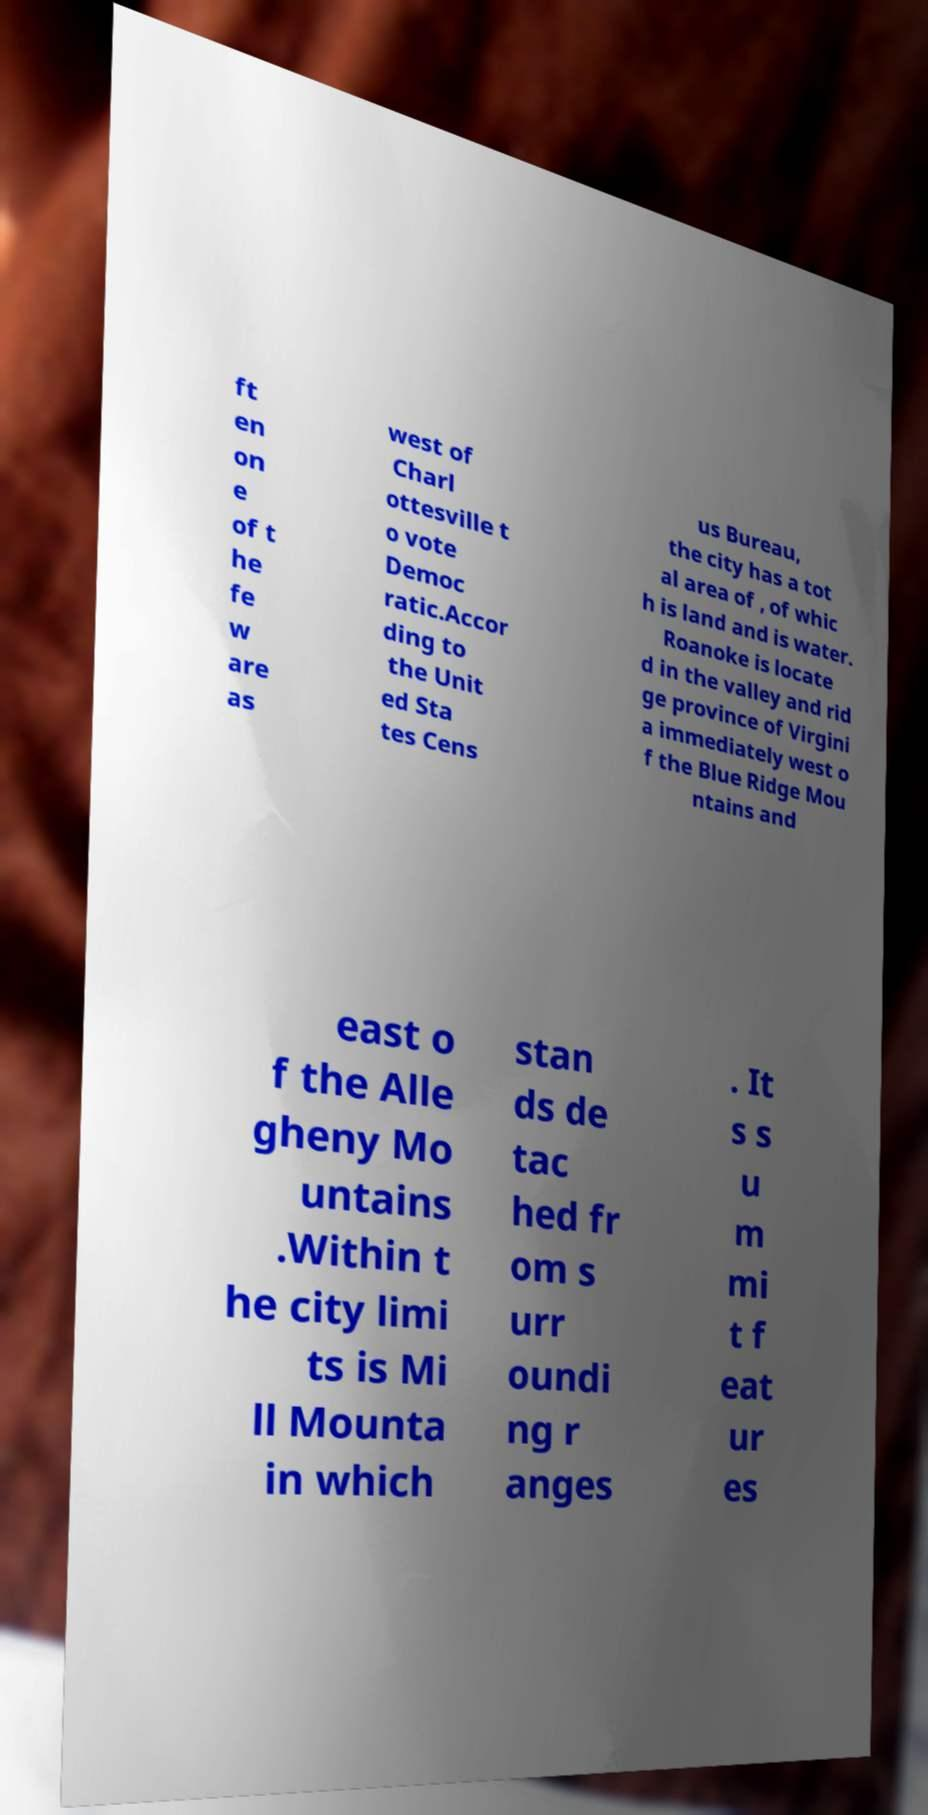Can you accurately transcribe the text from the provided image for me? ft en on e of t he fe w are as west of Charl ottesville t o vote Democ ratic.Accor ding to the Unit ed Sta tes Cens us Bureau, the city has a tot al area of , of whic h is land and is water. Roanoke is locate d in the valley and rid ge province of Virgini a immediately west o f the Blue Ridge Mou ntains and east o f the Alle gheny Mo untains .Within t he city limi ts is Mi ll Mounta in which stan ds de tac hed fr om s urr oundi ng r anges . It s s u m mi t f eat ur es 